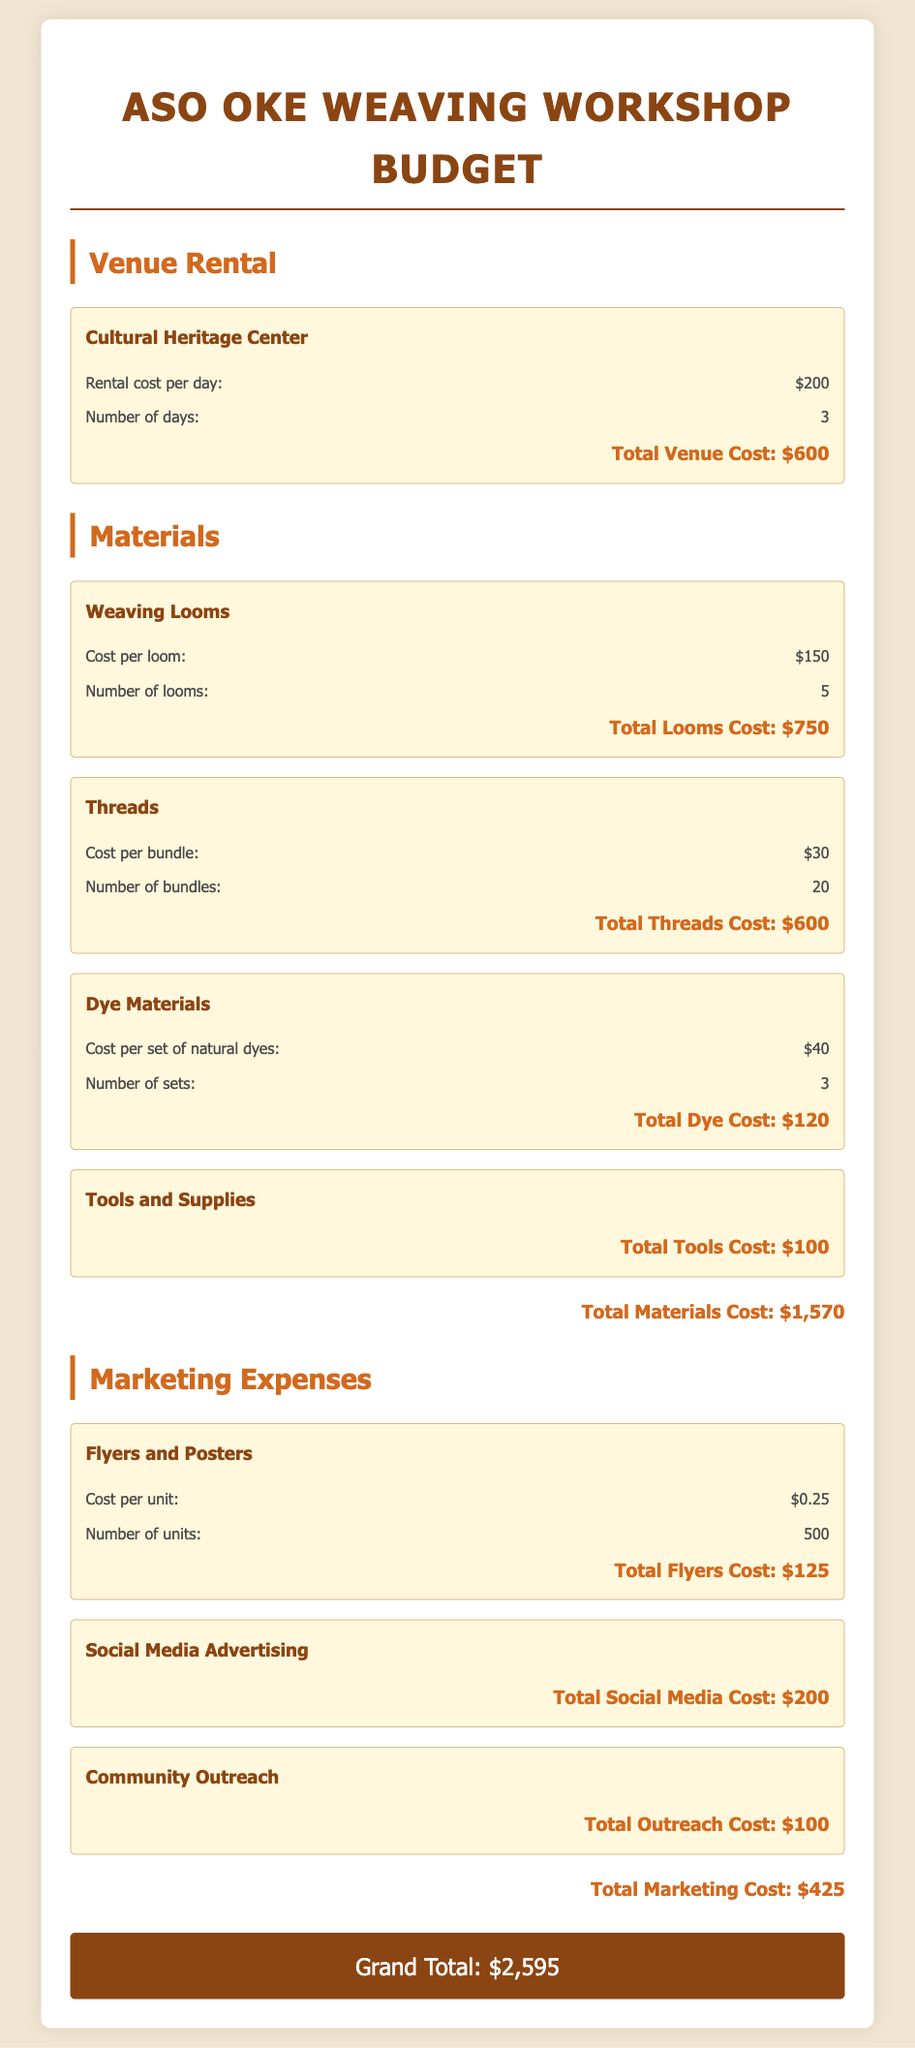What is the total venue cost? The total venue cost is calculated by multiplying the rental cost per day by the number of days, which is $200 per day for 3 days.
Answer: $600 How many looms are needed? The document specifies the number of looms required for the workshop is 5.
Answer: 5 What is the cost per bundle of threads? The document indicates that the cost per bundle of threads is $30.
Answer: $30 What is the total cost for dye materials? The total cost for dye materials is the cost of the natural dyes multiplied by the number of sets, totaling $120.
Answer: $120 What is the total marketing cost? The total marketing cost represents the sum of all marketing expenses listed, which is $425.
Answer: $425 How many units of flyers will be printed? The document states that the number of unit flyers to be printed is 500.
Answer: 500 What is the grand total for the workshop budget? The grand total is the sum of all individual costs from venue, materials, and marketing, which totals $2,595.
Answer: $2,595 What type of venue is being used for the workshops? The venue for the workshops is specified as the Cultural Heritage Center.
Answer: Cultural Heritage Center What is the total cost of tools and supplies? The total cost for tools and supplies is stated as $100 in the document.
Answer: $100 